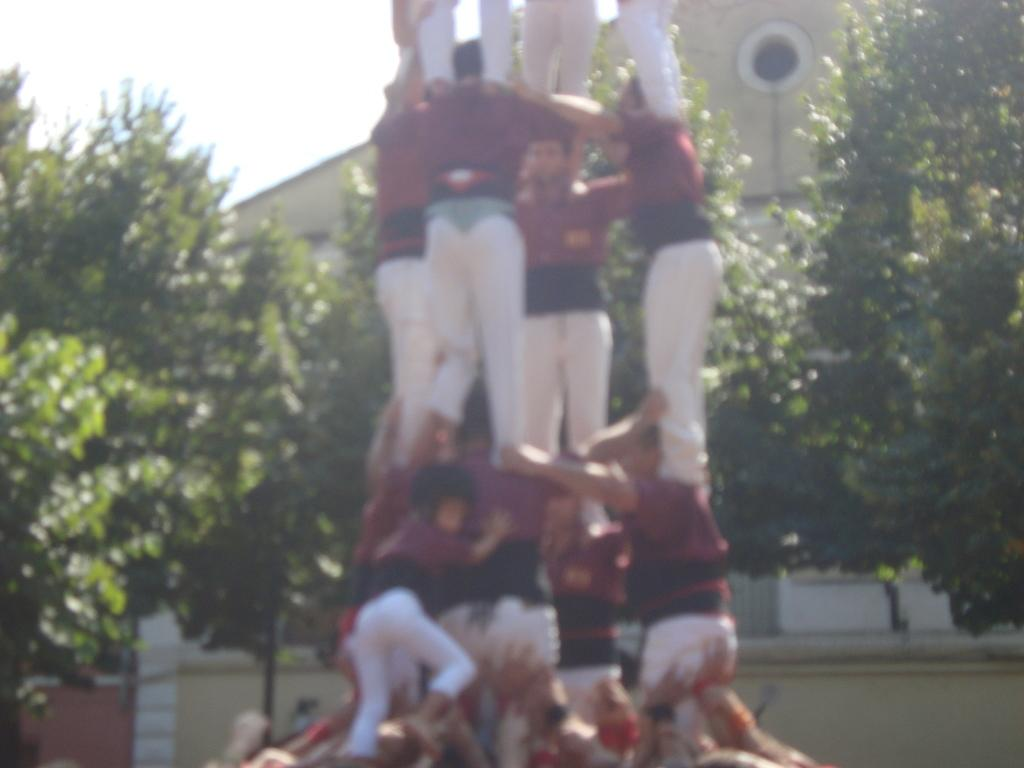What are the people in the image doing? The people in the image are standing in a formation resembling a tower. What can be seen in the background of the image? There are trees and buildings visible in the background. What part of the sky is visible in the image? The sky is visible in the top left side of the image. What type of meat is being grilled on the slope in the image? There is no meat or slope present in the image; it features people standing in a formation and a background with trees and buildings. 